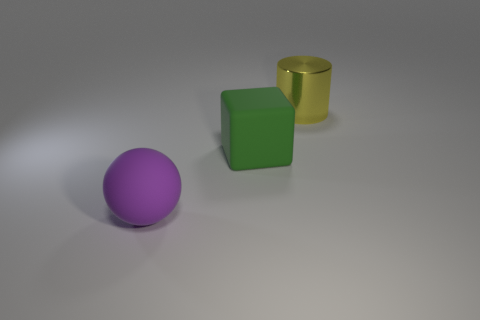Add 1 large cyan metallic balls. How many objects exist? 4 Subtract 1 cylinders. How many cylinders are left? 0 Subtract all balls. How many objects are left? 2 Add 3 large things. How many large things exist? 6 Subtract 0 cyan blocks. How many objects are left? 3 Subtract all blue cylinders. Subtract all gray spheres. How many cylinders are left? 1 Subtract all purple cylinders. How many brown cubes are left? 0 Subtract all green things. Subtract all big purple matte balls. How many objects are left? 1 Add 1 rubber things. How many rubber things are left? 3 